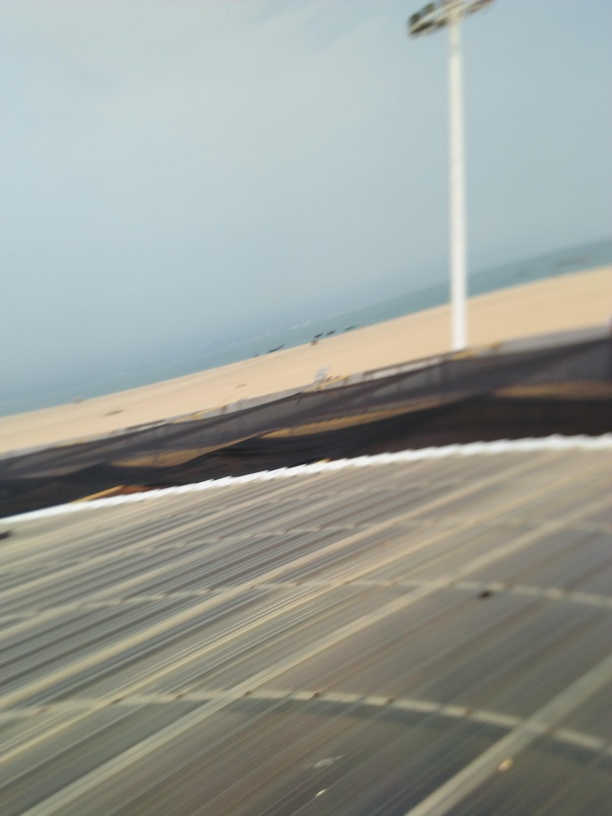What caused a loss of texture details in the image?
A. Artistic effects
B. Motion blur
C. Camera settings
D. Lighting conditions
Answer with the option's letter from the given choices directly.
 B. 